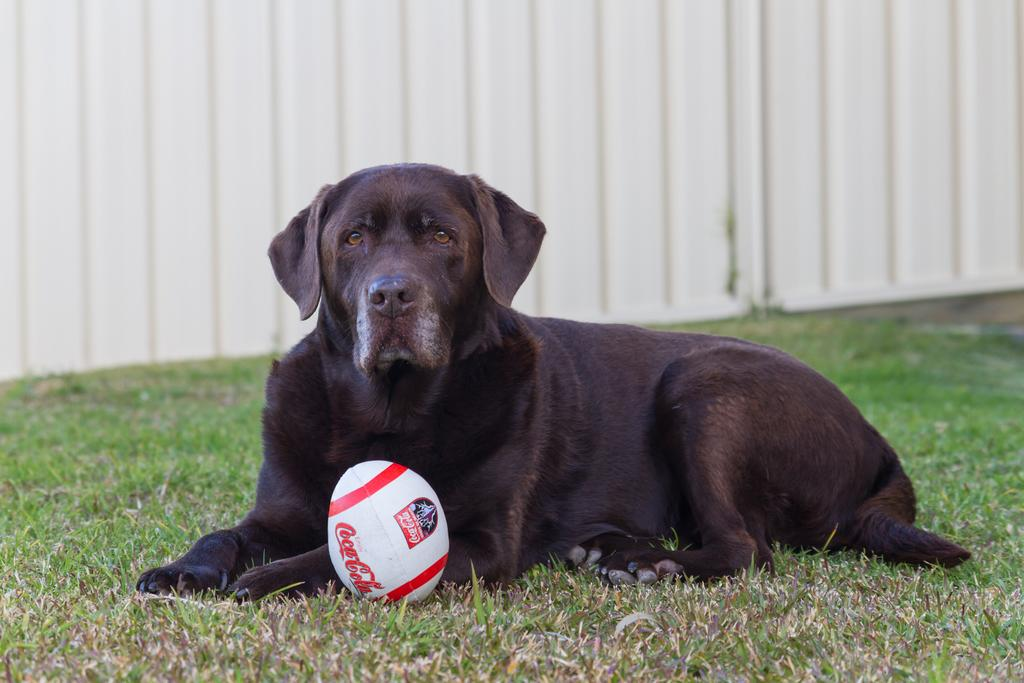What is the main subject of the image? There is a dog in the center of the image. Where is the dog located? The dog is on the grass. What can be seen in the background of the image? There is a wall in the background of the image. What type of pump is being used to increase the dog's energy in the image? There is no pump or any indication of energy increase in the image; it simply shows a dog on the grass with a wall in the background. 